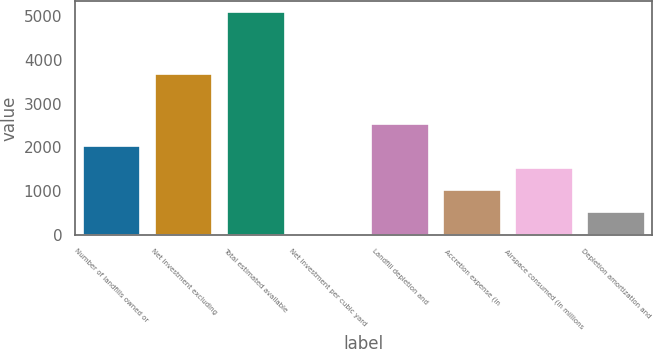<chart> <loc_0><loc_0><loc_500><loc_500><bar_chart><fcel>Number of landfills owned or<fcel>Net investment excluding<fcel>Total estimated available<fcel>Net investment per cubic yard<fcel>Landfill depletion and<fcel>Accretion expense (in<fcel>Airspace consumed (in millions<fcel>Depletion amortization and<nl><fcel>2034.84<fcel>3673.2<fcel>5086<fcel>0.72<fcel>2543.37<fcel>1017.78<fcel>1526.31<fcel>509.25<nl></chart> 